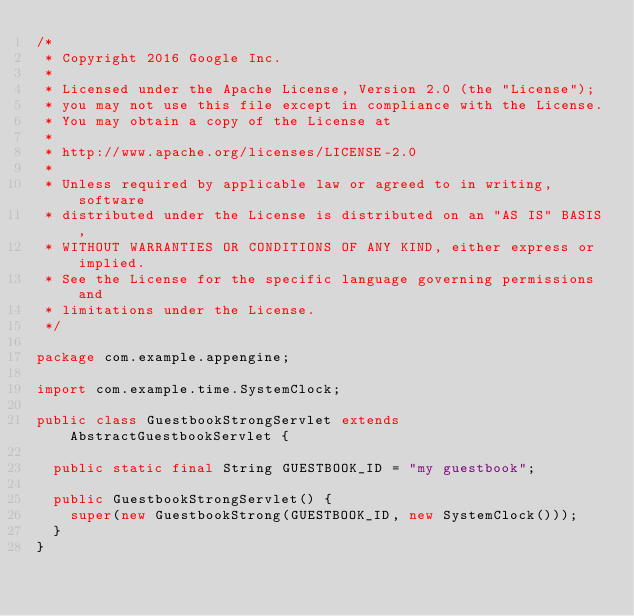Convert code to text. <code><loc_0><loc_0><loc_500><loc_500><_Java_>/*
 * Copyright 2016 Google Inc.
 *
 * Licensed under the Apache License, Version 2.0 (the "License");
 * you may not use this file except in compliance with the License.
 * You may obtain a copy of the License at
 *
 * http://www.apache.org/licenses/LICENSE-2.0
 *
 * Unless required by applicable law or agreed to in writing, software
 * distributed under the License is distributed on an "AS IS" BASIS,
 * WITHOUT WARRANTIES OR CONDITIONS OF ANY KIND, either express or implied.
 * See the License for the specific language governing permissions and
 * limitations under the License.
 */

package com.example.appengine;

import com.example.time.SystemClock;

public class GuestbookStrongServlet extends AbstractGuestbookServlet {

  public static final String GUESTBOOK_ID = "my guestbook";

  public GuestbookStrongServlet() {
    super(new GuestbookStrong(GUESTBOOK_ID, new SystemClock()));
  }
}
</code> 